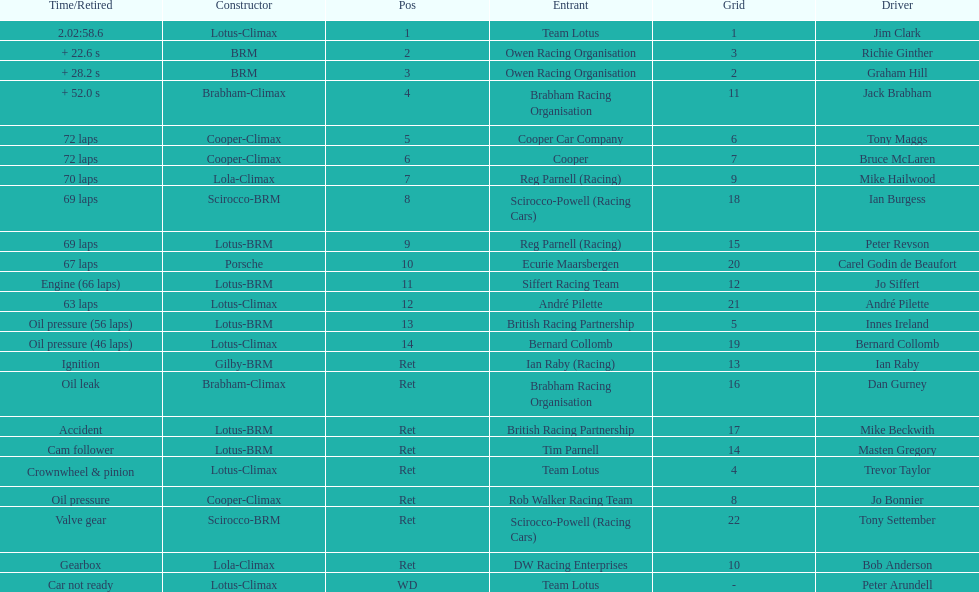What is the number of americans in the top 5? 1. 